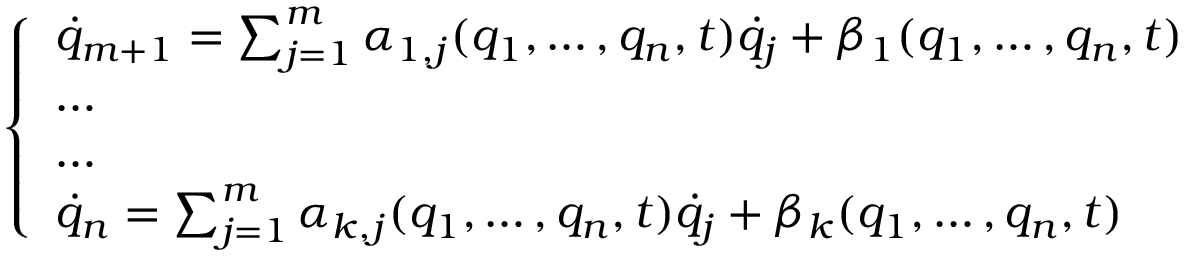<formula> <loc_0><loc_0><loc_500><loc_500>\left \{ \begin{array} { l l } { { \dot { q } } _ { m + 1 } = \sum _ { j = 1 } ^ { m } \alpha _ { 1 , j } ( q _ { 1 } , \dots , q _ { n } , t ) { \dot { q } } _ { j } + \beta _ { 1 } ( q _ { 1 } , \dots , q _ { n } , t ) } \\ { \dots } \\ { \dots } \\ { { \dot { q } } _ { n } = \sum _ { j = 1 } ^ { m } \alpha _ { k , j } ( q _ { 1 } , \dots , q _ { n } , t ) { \dot { q } } _ { j } + \beta _ { k } ( q _ { 1 } , \dots , q _ { n } , t ) } \end{array}</formula> 